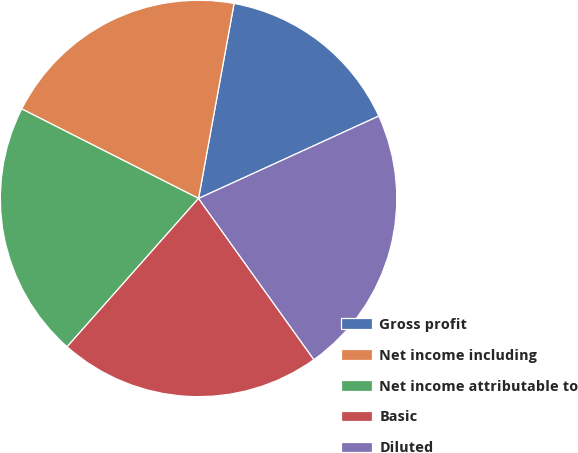Convert chart. <chart><loc_0><loc_0><loc_500><loc_500><pie_chart><fcel>Gross profit<fcel>Net income including<fcel>Net income attributable to<fcel>Basic<fcel>Diluted<nl><fcel>15.31%<fcel>20.41%<fcel>20.92%<fcel>21.43%<fcel>21.94%<nl></chart> 